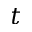<formula> <loc_0><loc_0><loc_500><loc_500>t</formula> 